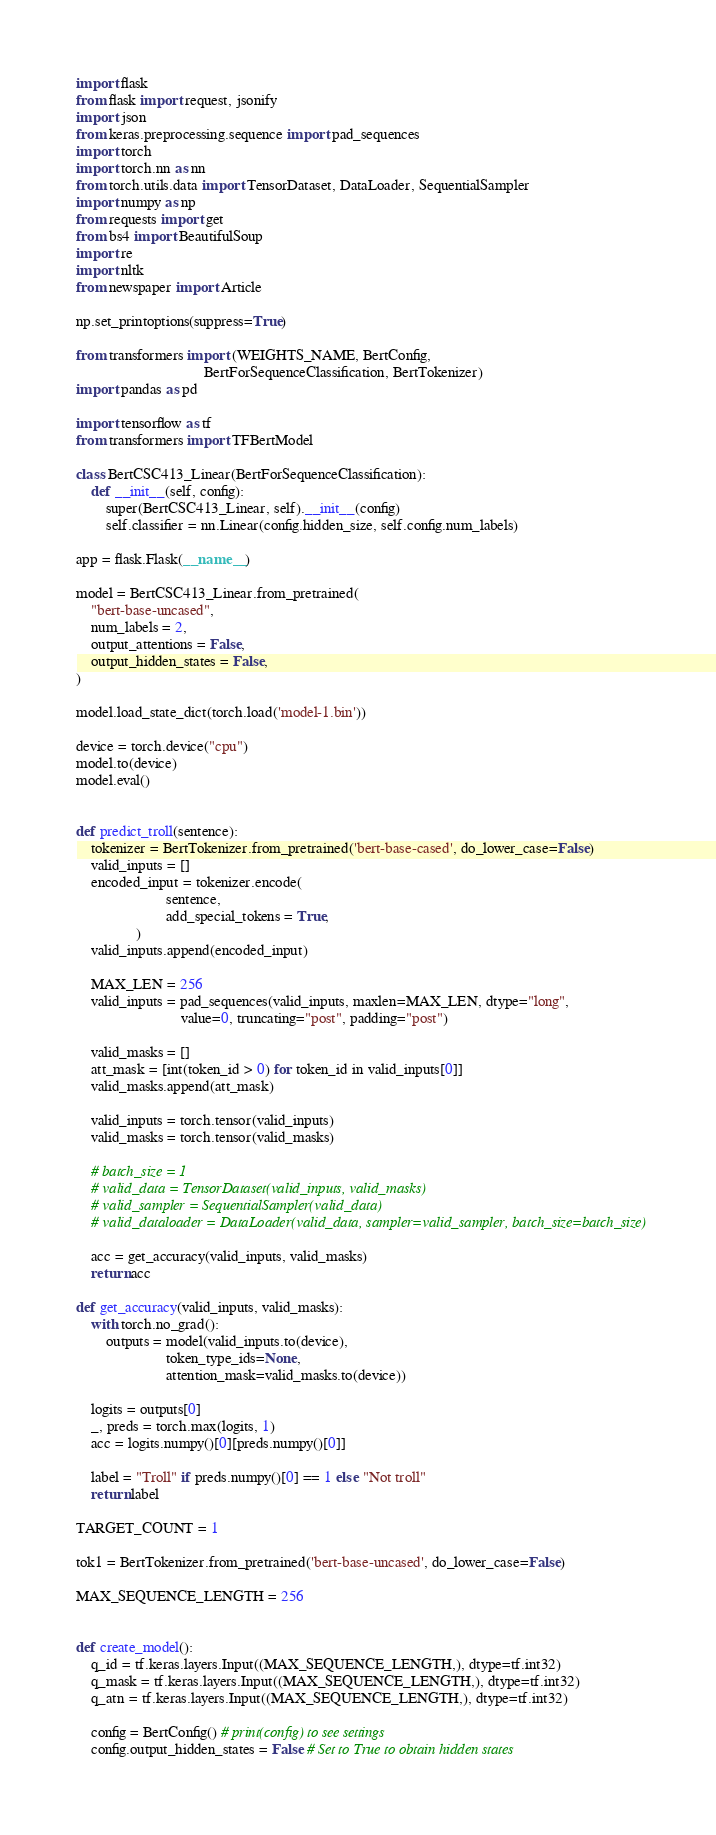Convert code to text. <code><loc_0><loc_0><loc_500><loc_500><_Python_>import flask
from flask import request, jsonify
import json
from keras.preprocessing.sequence import pad_sequences
import torch
import torch.nn as nn
from torch.utils.data import TensorDataset, DataLoader, SequentialSampler
import numpy as np
from requests import get
from bs4 import BeautifulSoup
import re
import nltk
from newspaper import Article

np.set_printoptions(suppress=True)

from transformers import (WEIGHTS_NAME, BertConfig,
                                  BertForSequenceClassification, BertTokenizer)
import pandas as pd

import tensorflow as tf
from transformers import TFBertModel

class BertCSC413_Linear(BertForSequenceClassification):
    def __init__(self, config):
        super(BertCSC413_Linear, self).__init__(config)
        self.classifier = nn.Linear(config.hidden_size, self.config.num_labels)

app = flask.Flask(__name__)

model = BertCSC413_Linear.from_pretrained(
    "bert-base-uncased", 
    num_labels = 2,    
    output_attentions = False, 
    output_hidden_states = False,
)

model.load_state_dict(torch.load('model-1.bin'))

device = torch.device("cpu")
model.to(device)
model.eval()


def predict_troll(sentence):
    tokenizer = BertTokenizer.from_pretrained('bert-base-cased', do_lower_case=False)
    valid_inputs = []
    encoded_input = tokenizer.encode(
                        sentence,
                        add_special_tokens = True,
                )
    valid_inputs.append(encoded_input)

    MAX_LEN = 256
    valid_inputs = pad_sequences(valid_inputs, maxlen=MAX_LEN, dtype="long", 
                            value=0, truncating="post", padding="post")

    valid_masks = []
    att_mask = [int(token_id > 0) for token_id in valid_inputs[0]]
    valid_masks.append(att_mask)

    valid_inputs = torch.tensor(valid_inputs)
    valid_masks = torch.tensor(valid_masks)

    # batch_size = 1
    # valid_data = TensorDataset(valid_inputs, valid_masks)
    # valid_sampler = SequentialSampler(valid_data)
    # valid_dataloader = DataLoader(valid_data, sampler=valid_sampler, batch_size=batch_size)

    acc = get_accuracy(valid_inputs, valid_masks)
    return acc

def get_accuracy(valid_inputs, valid_masks):
    with torch.no_grad():
        outputs = model(valid_inputs.to(device), 
                        token_type_ids=None, 
                        attention_mask=valid_masks.to(device))
    
    logits = outputs[0]
    _, preds = torch.max(logits, 1)
    acc = logits.numpy()[0][preds.numpy()[0]]

    label = "Troll" if preds.numpy()[0] == 1 else "Not troll"
    return label

TARGET_COUNT = 1

tok1 = BertTokenizer.from_pretrained('bert-base-uncased', do_lower_case=False)

MAX_SEQUENCE_LENGTH = 256


def create_model():
    q_id = tf.keras.layers.Input((MAX_SEQUENCE_LENGTH,), dtype=tf.int32)
    q_mask = tf.keras.layers.Input((MAX_SEQUENCE_LENGTH,), dtype=tf.int32)
    q_atn = tf.keras.layers.Input((MAX_SEQUENCE_LENGTH,), dtype=tf.int32)
    
    config = BertConfig() # print(config) to see settings
    config.output_hidden_states = False # Set to True to obtain hidden states</code> 